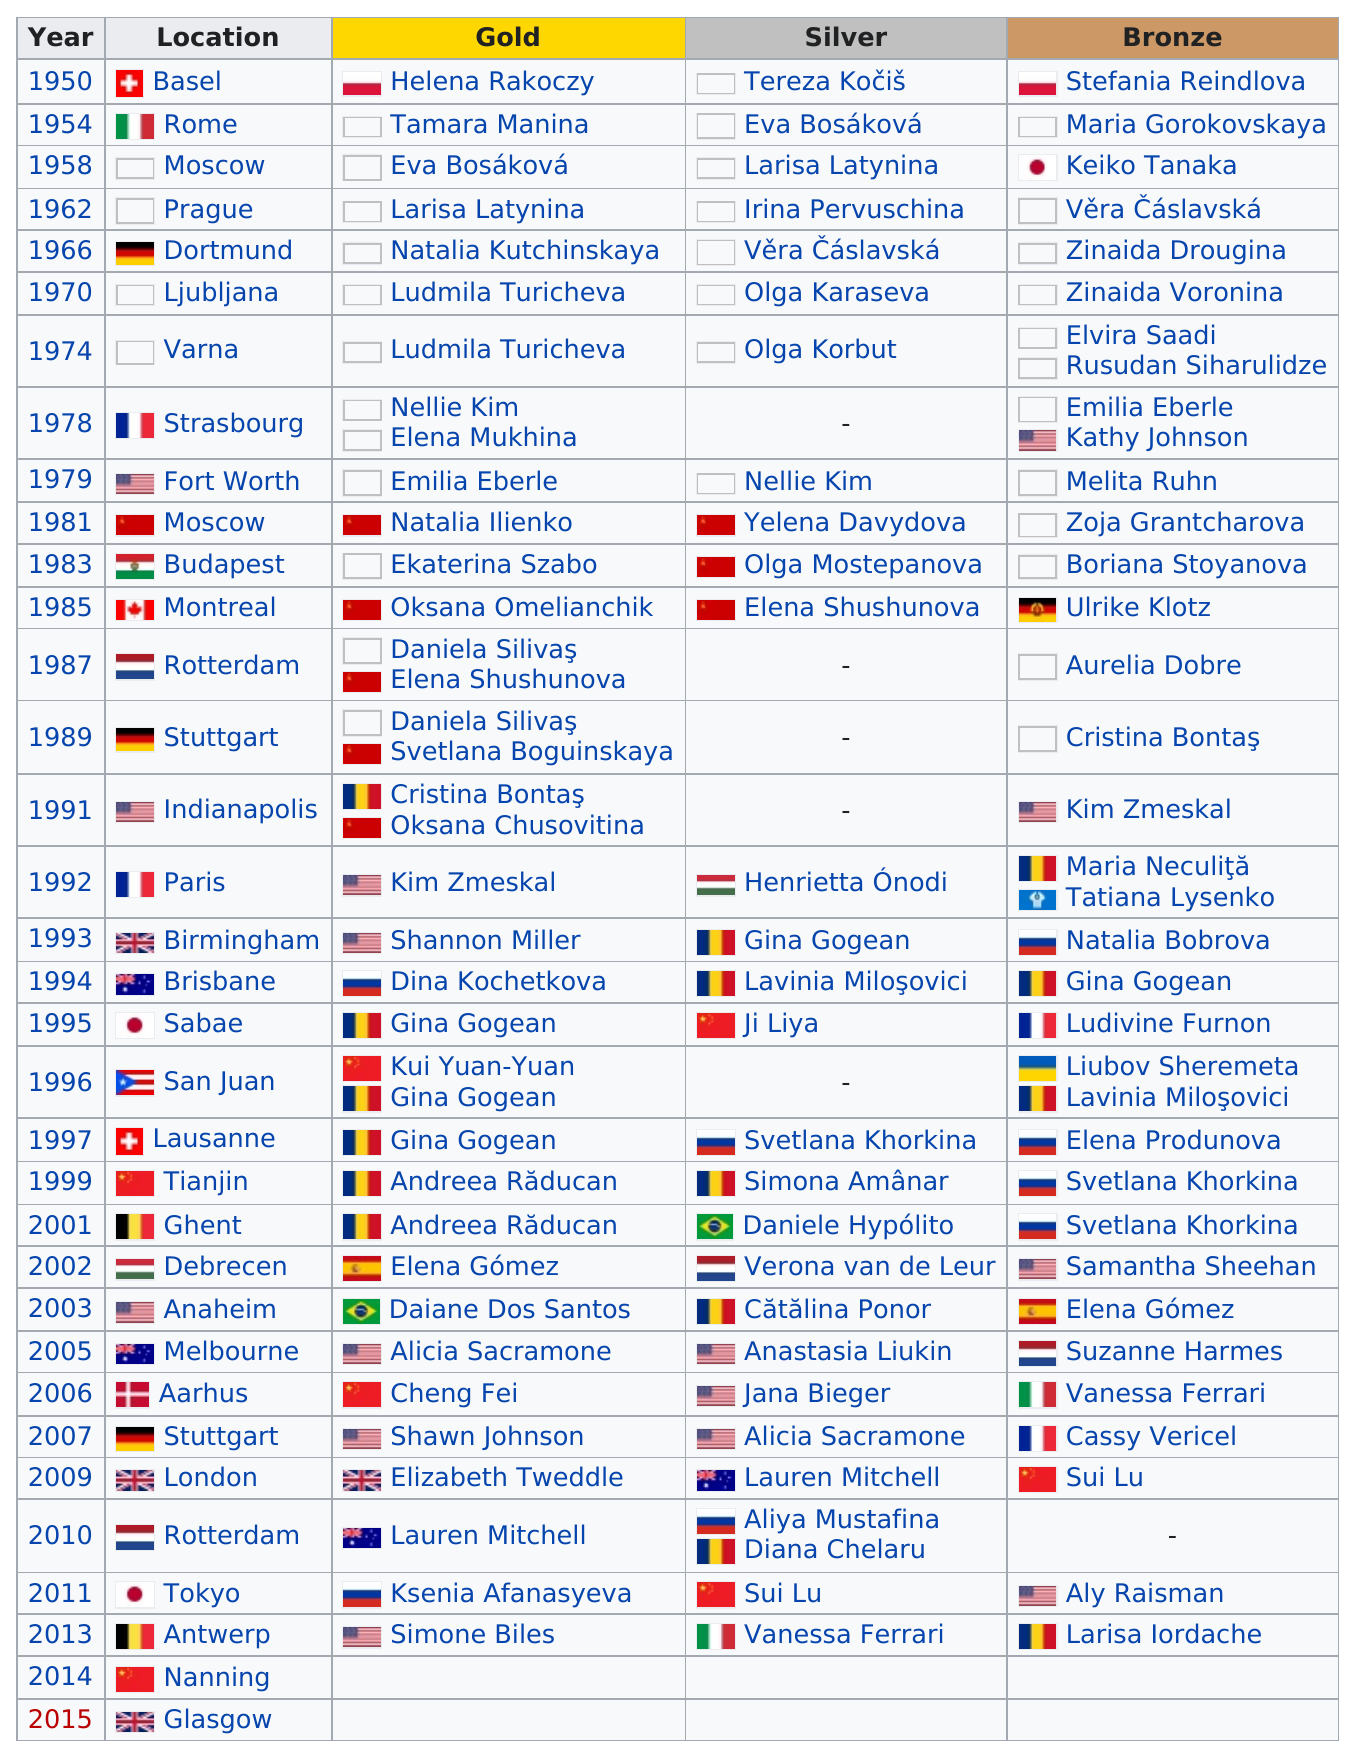Point out several critical features in this image. Eight Russian gymnasts have won the silver medal in total. Andreea Raducan won two consecutive gold medals in the floor exercise at the World Championships. It is known that Brazilians have won a total of two medals. In 1992 and 1993, American gymnasts Kim Zmeskal and Shannon Miller won consecutive gold medals in the floor exercise event at the Artistic Gymnastics World Championships. The location was in the United States three times. 